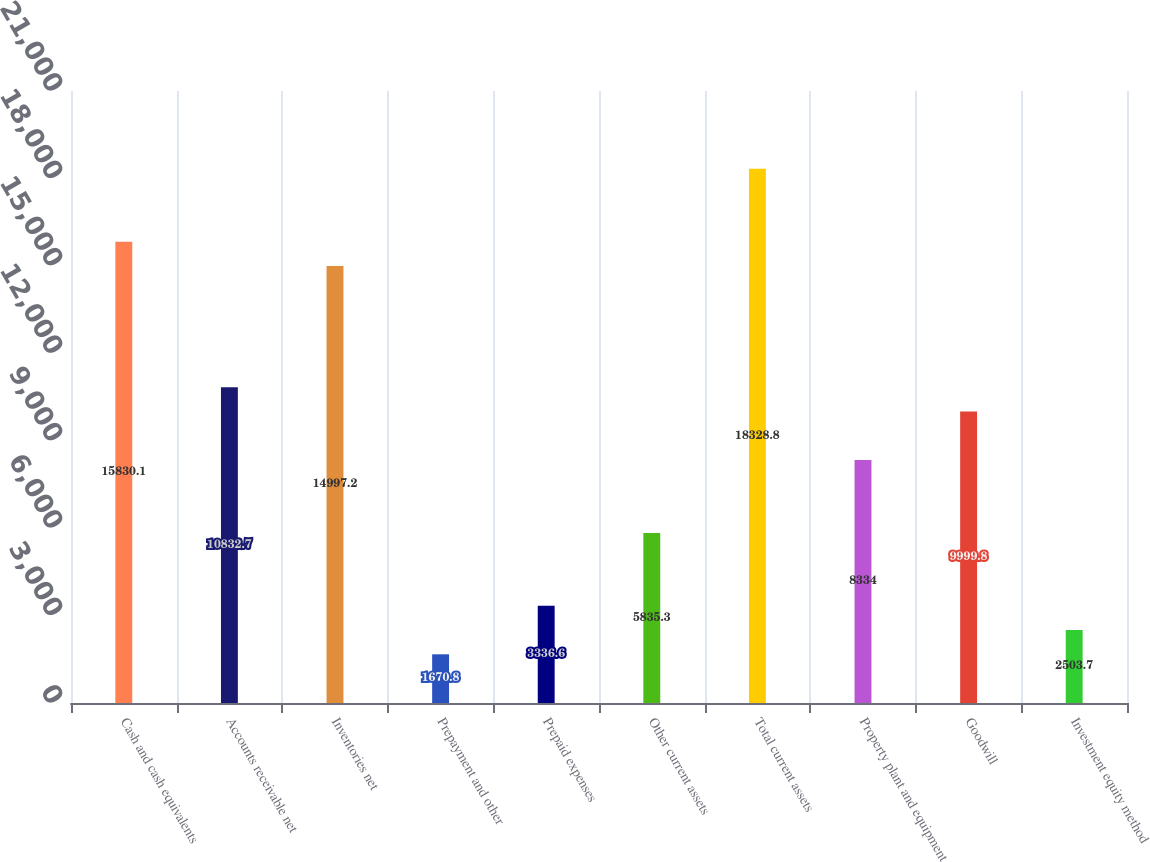<chart> <loc_0><loc_0><loc_500><loc_500><bar_chart><fcel>Cash and cash equivalents<fcel>Accounts receivable net<fcel>Inventories net<fcel>Prepayment and other<fcel>Prepaid expenses<fcel>Other current assets<fcel>Total current assets<fcel>Property plant and equipment<fcel>Goodwill<fcel>Investment equity method<nl><fcel>15830.1<fcel>10832.7<fcel>14997.2<fcel>1670.8<fcel>3336.6<fcel>5835.3<fcel>18328.8<fcel>8334<fcel>9999.8<fcel>2503.7<nl></chart> 